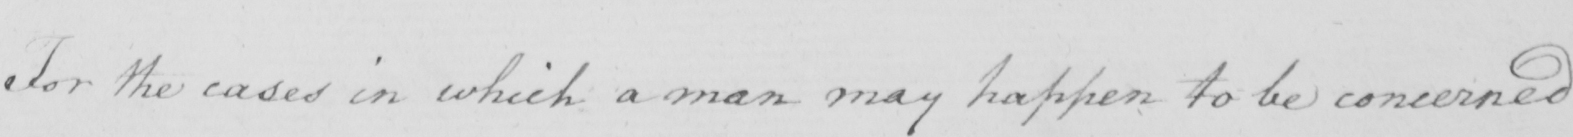Transcribe the text shown in this historical manuscript line. For the cases in which a man may happen to be concerned 